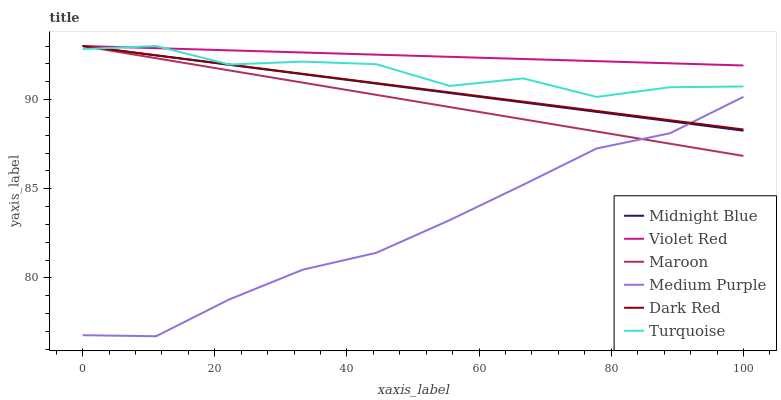Does Medium Purple have the minimum area under the curve?
Answer yes or no. Yes. Does Violet Red have the maximum area under the curve?
Answer yes or no. Yes. Does Midnight Blue have the minimum area under the curve?
Answer yes or no. No. Does Midnight Blue have the maximum area under the curve?
Answer yes or no. No. Is Midnight Blue the smoothest?
Answer yes or no. Yes. Is Turquoise the roughest?
Answer yes or no. Yes. Is Dark Red the smoothest?
Answer yes or no. No. Is Dark Red the roughest?
Answer yes or no. No. Does Medium Purple have the lowest value?
Answer yes or no. Yes. Does Midnight Blue have the lowest value?
Answer yes or no. No. Does Maroon have the highest value?
Answer yes or no. Yes. Does Medium Purple have the highest value?
Answer yes or no. No. Is Medium Purple less than Violet Red?
Answer yes or no. Yes. Is Turquoise greater than Medium Purple?
Answer yes or no. Yes. Does Midnight Blue intersect Violet Red?
Answer yes or no. Yes. Is Midnight Blue less than Violet Red?
Answer yes or no. No. Is Midnight Blue greater than Violet Red?
Answer yes or no. No. Does Medium Purple intersect Violet Red?
Answer yes or no. No. 